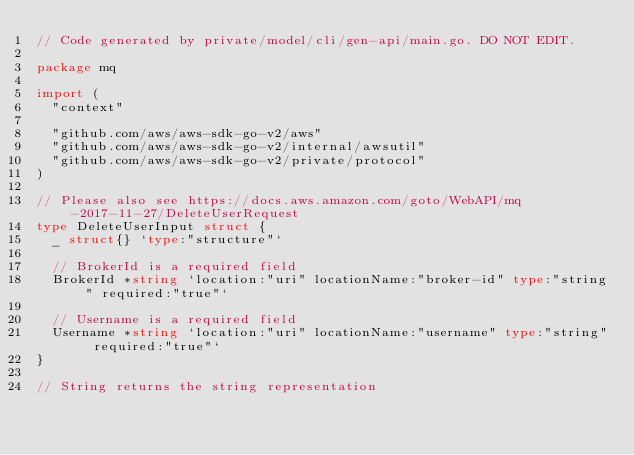<code> <loc_0><loc_0><loc_500><loc_500><_Go_>// Code generated by private/model/cli/gen-api/main.go. DO NOT EDIT.

package mq

import (
	"context"

	"github.com/aws/aws-sdk-go-v2/aws"
	"github.com/aws/aws-sdk-go-v2/internal/awsutil"
	"github.com/aws/aws-sdk-go-v2/private/protocol"
)

// Please also see https://docs.aws.amazon.com/goto/WebAPI/mq-2017-11-27/DeleteUserRequest
type DeleteUserInput struct {
	_ struct{} `type:"structure"`

	// BrokerId is a required field
	BrokerId *string `location:"uri" locationName:"broker-id" type:"string" required:"true"`

	// Username is a required field
	Username *string `location:"uri" locationName:"username" type:"string" required:"true"`
}

// String returns the string representation</code> 